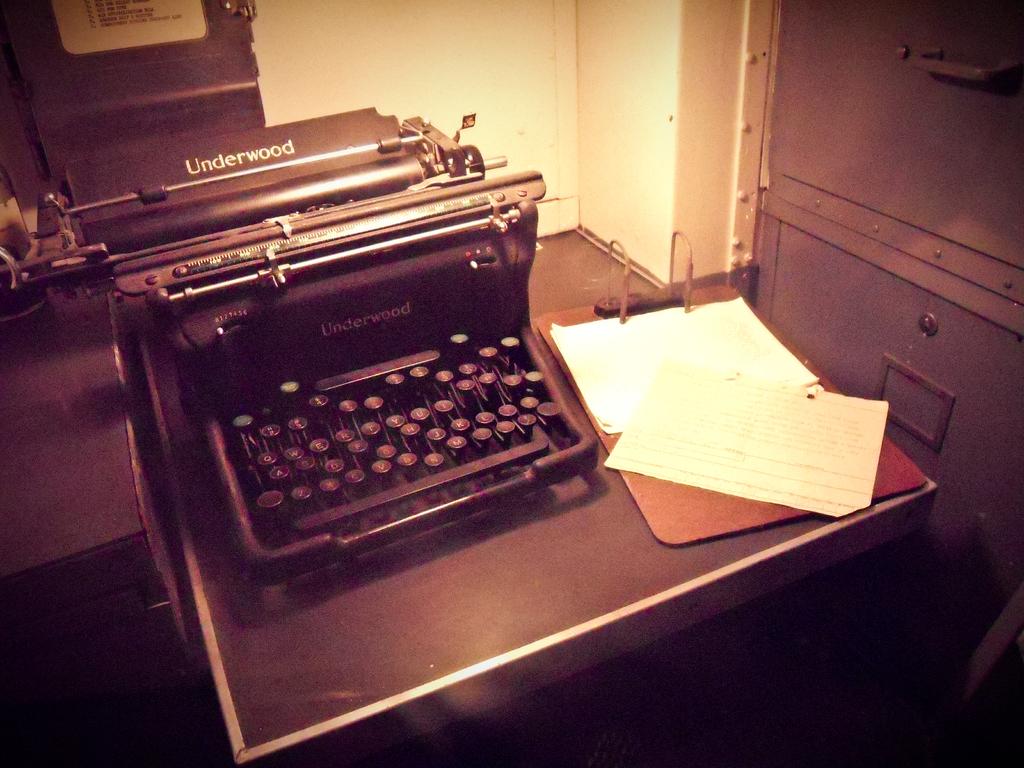What's the name on the typewriter?
Give a very brief answer. Underwood. 